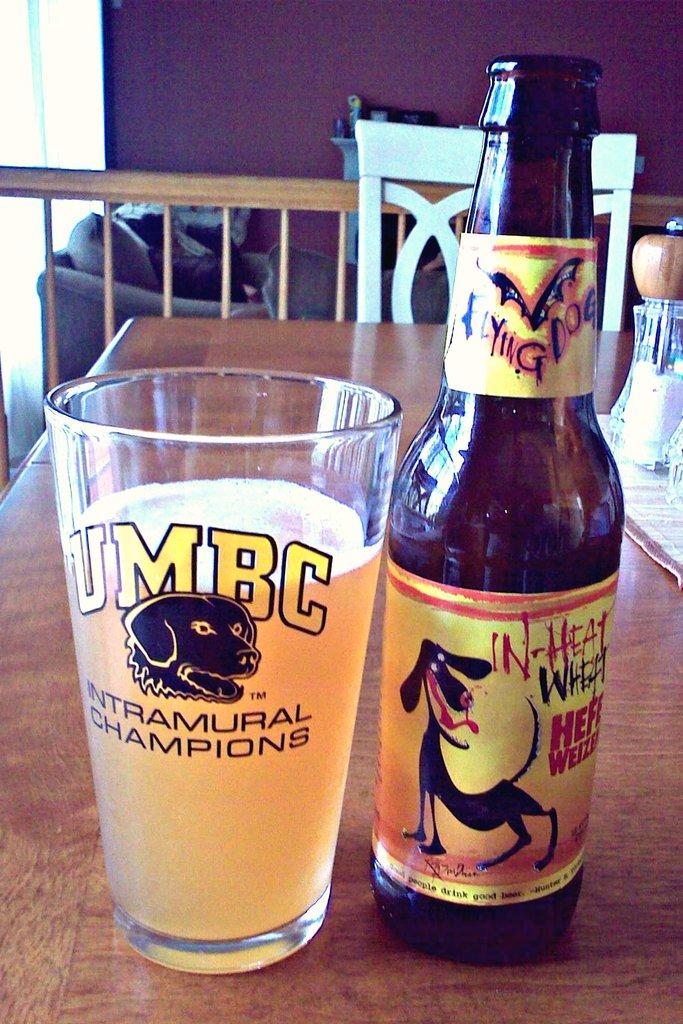<image>
Relay a brief, clear account of the picture shown. A Flying Dog brand beer bottle is pictured on a table next to a cup of beer with the acronym UMBC and the words "intramural champions" on it. 